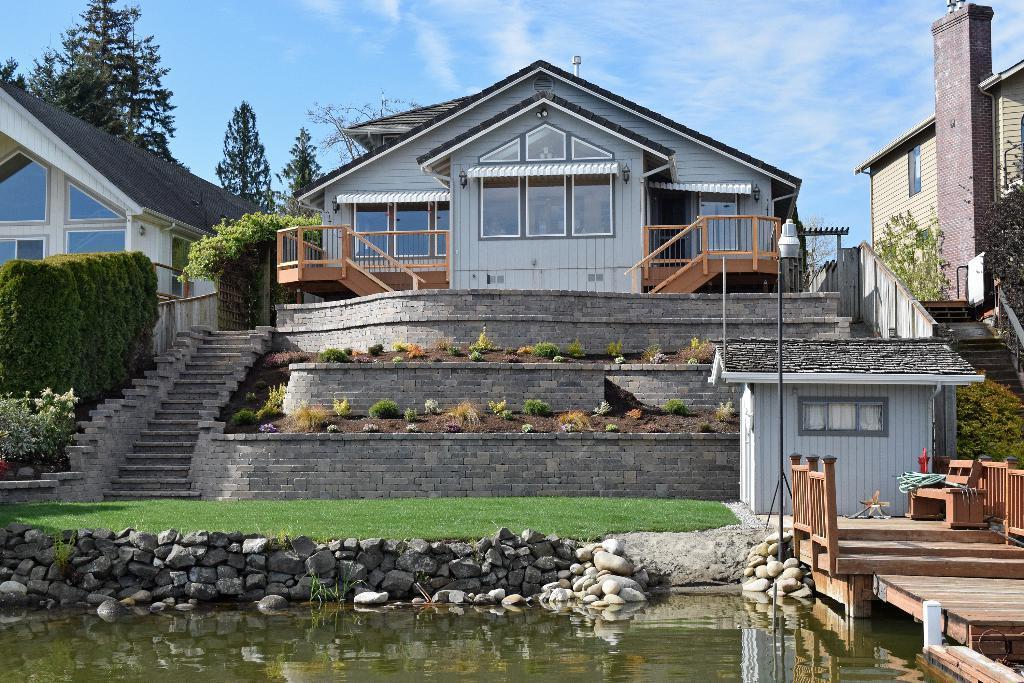In one or two sentences, can you explain what this image depicts? Here we can see water, stones, houses, grass, plants and wall. Background we can see trees and sky. 